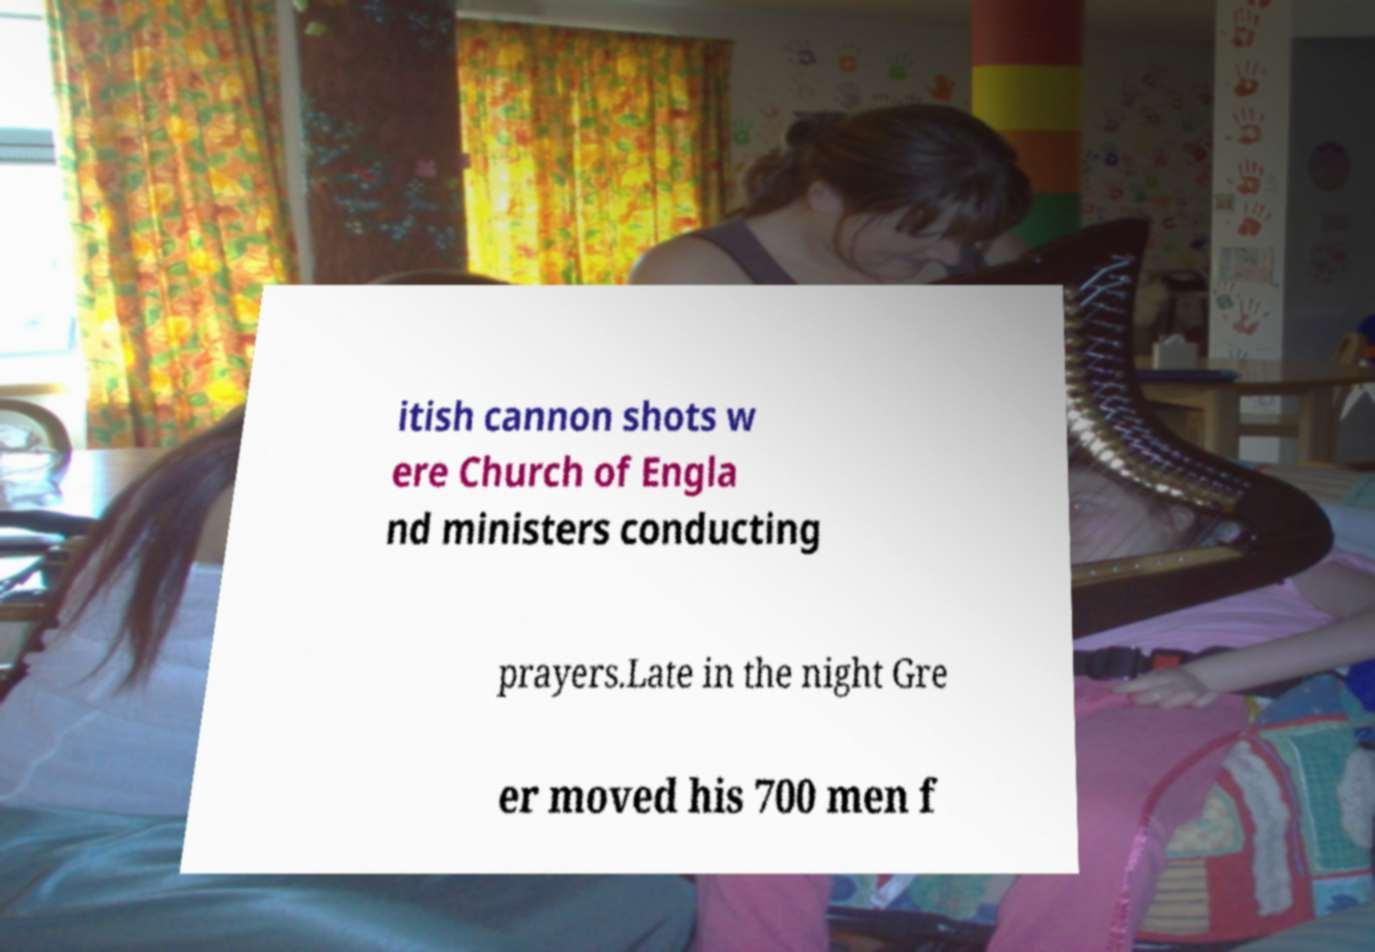Please read and relay the text visible in this image. What does it say? itish cannon shots w ere Church of Engla nd ministers conducting prayers.Late in the night Gre er moved his 700 men f 